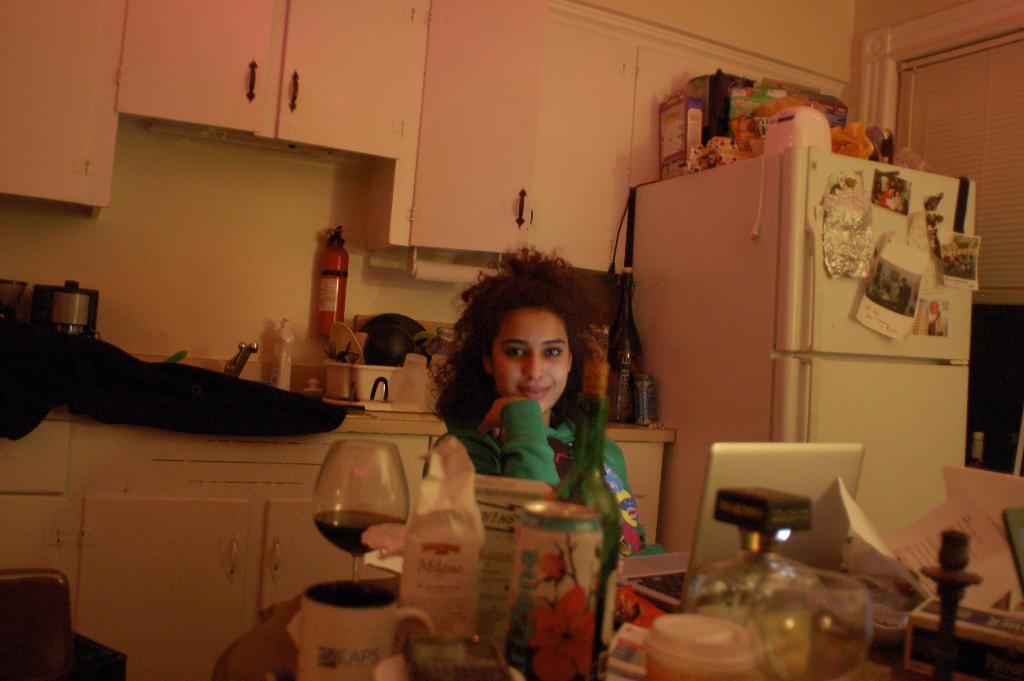Can you describe this image briefly? In the middle of the image, there is a woman sitting on the chair, in front of the table on which glass, cans, laptop, papers, boxes and tea cups are kept. In the background there are shelves in the kitchen. In the right, fridge is there white in color. The wall is white in color. In the top right, window is visible. This image is taken inside a kitchen. 